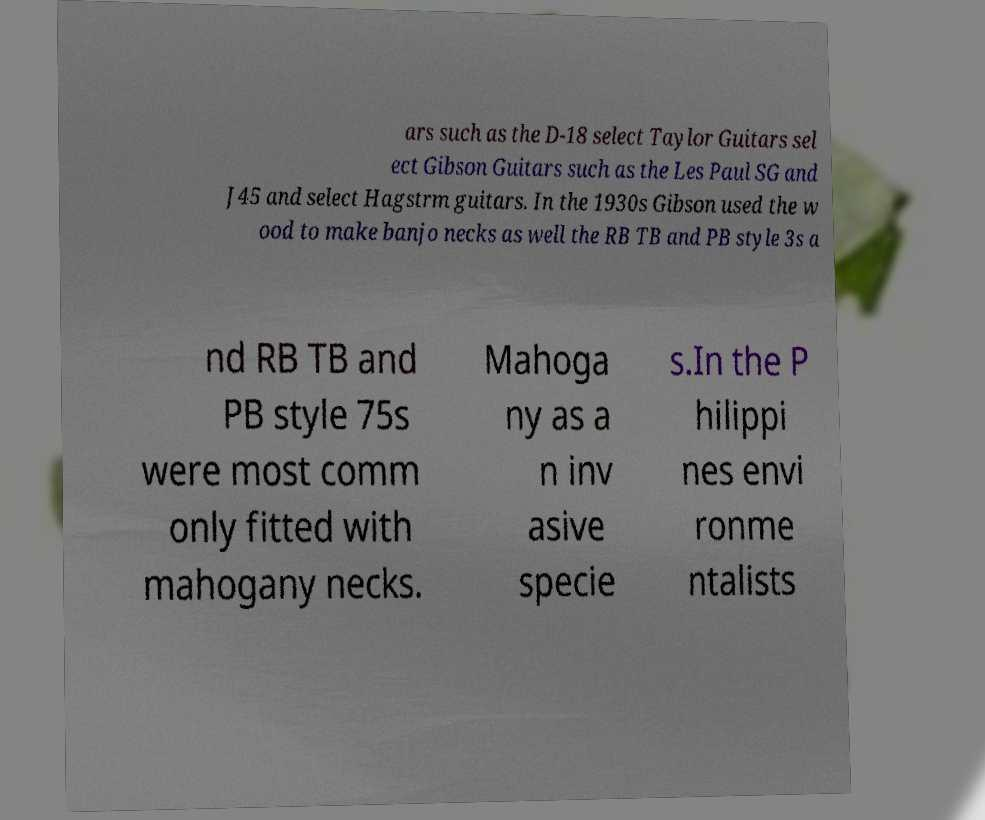What messages or text are displayed in this image? I need them in a readable, typed format. ars such as the D-18 select Taylor Guitars sel ect Gibson Guitars such as the Les Paul SG and J45 and select Hagstrm guitars. In the 1930s Gibson used the w ood to make banjo necks as well the RB TB and PB style 3s a nd RB TB and PB style 75s were most comm only fitted with mahogany necks. Mahoga ny as a n inv asive specie s.In the P hilippi nes envi ronme ntalists 